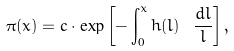<formula> <loc_0><loc_0><loc_500><loc_500>\pi ( x ) = c \cdot \exp \left [ - \int _ { 0 } ^ { x } h ( l ) \ \frac { d l } { l } \right ] ,</formula> 